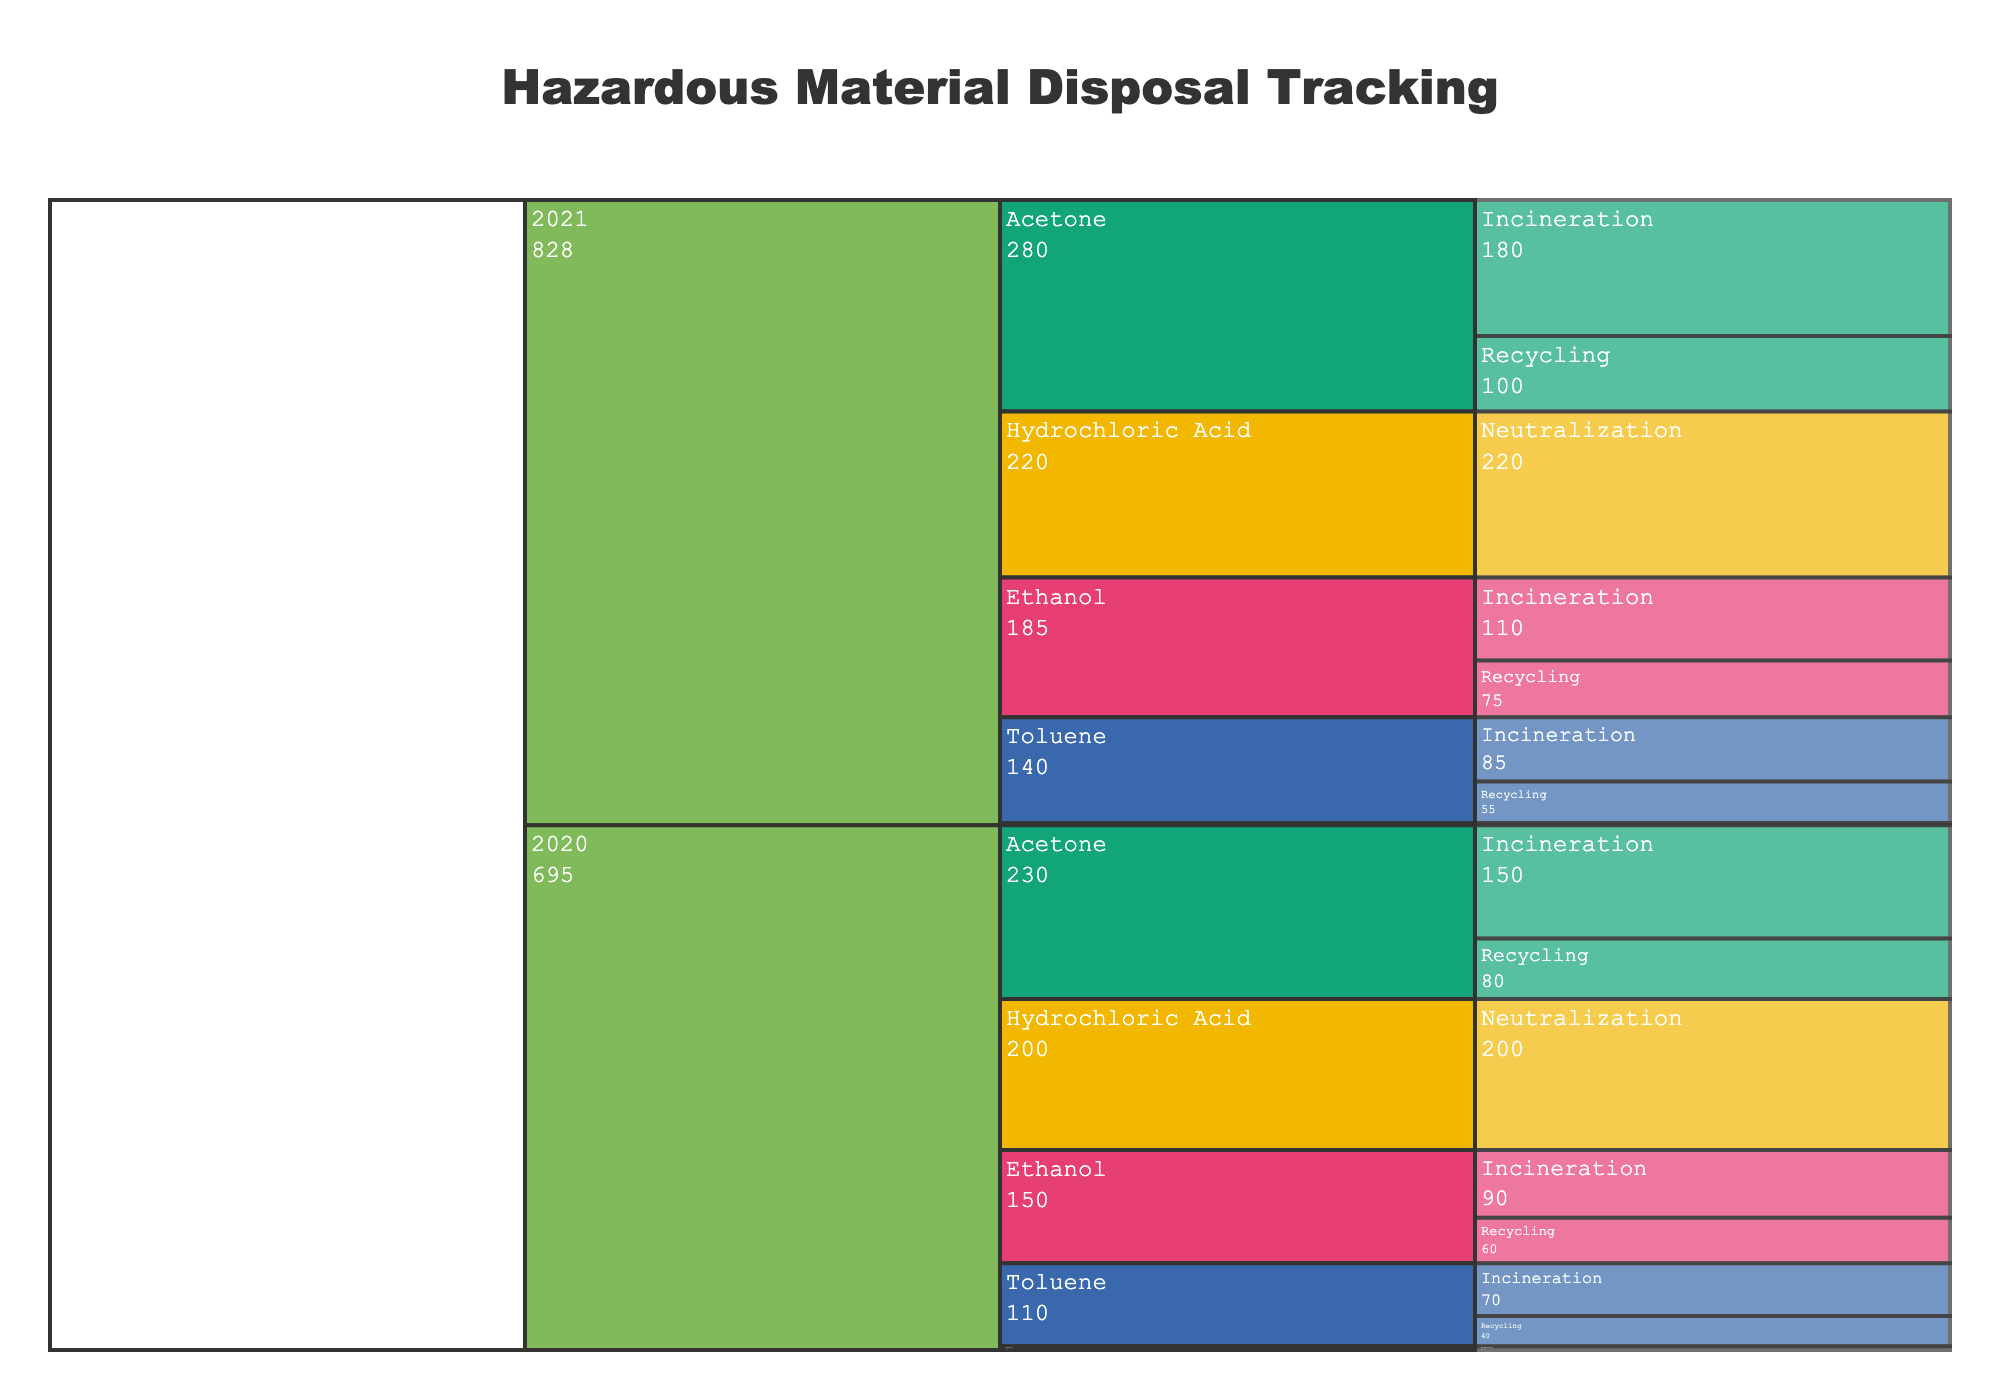What's the title of the icicle chart? Look at the top center of the chart to find the title. The title helps to understand what the visualization is about.
Answer: Hazardous Material Disposal Tracking How many chemical types are displayed in the chart? View the different boxes at the top level under each year, each representing a unique chemical type.
Answer: 5 Which year had the highest total disposal quantity? Analyze the width and height of the segments for each year. Year with the largest combined area for all chemicals has the highest total quantity.
Answer: 2021 Which disposal method was used the most for Acetone in 2021? Look at the sub-segments for Acetone in 2021 and compare their sizes. The largest sub-segment indicates the most used disposal method.
Answer: Incineration What's the total quantity of Hydrochloric Acid disposed of over the two years? Add the quantities from both years (2020 and 2021) for Hydrochloric Acid.
Answer: 420 kg Which chemical had the lowest quantity disposed of in 2020? Examine the segments for each chemical in 2020 and identify the smallest segment.
Answer: Mercury Did the total disposal quantity of Ethanol increase or decrease from 2020 to 2021? Compare the sizes of Ethanol segments between 2020 and 2021. Determine if the overall size is bigger or smaller in 2021.
Answer: Increase How many different disposal methods were used for Toluene in 2020? Identify the distinct sub-segments under Toluene for the year 2020. Count the number of unique methods.
Answer: 2 Which disposal method for Ethanol saw the largest growth from 2020 to 2021? Compare the size of each disposal method sub-segment for Ethanol between the two years. Determine which disposal method had the largest increase in size.
Answer: Incineration What's the average disposed quantity of Acetone per year across both years? Add the quantities for both years (150+80+180+100) = 510 kg. Divide by the number of years (510/2).
Answer: 255 kg 